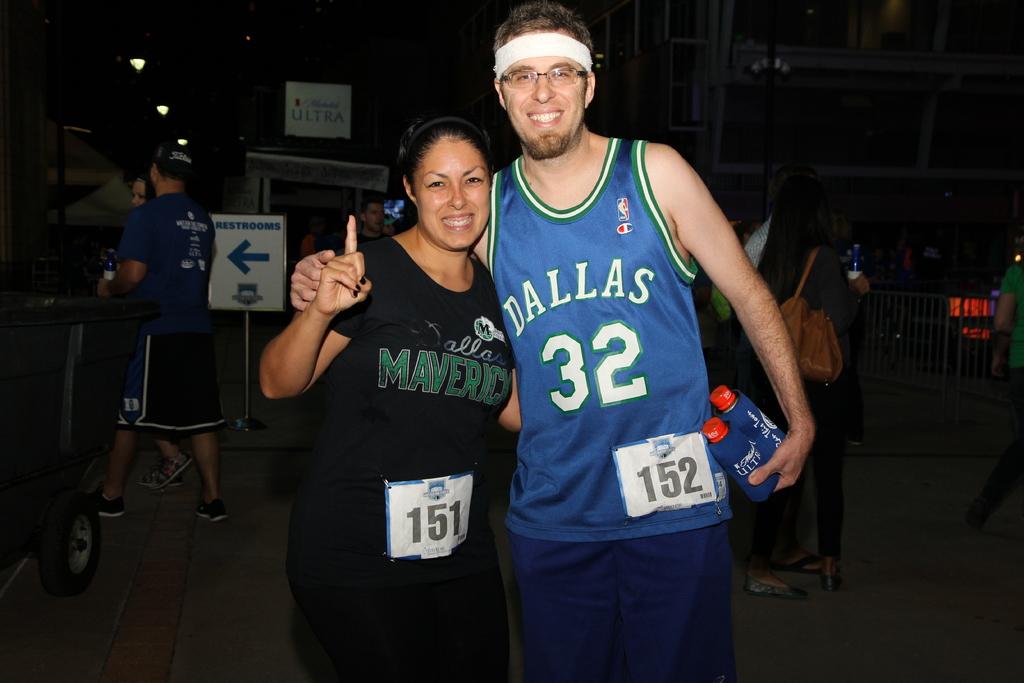What team is on the blue jersey?
Keep it short and to the point. Dallas. 